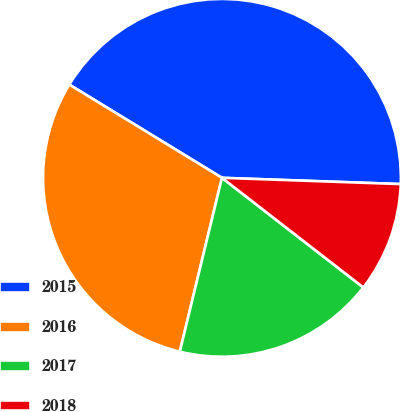Convert chart. <chart><loc_0><loc_0><loc_500><loc_500><pie_chart><fcel>2015<fcel>2016<fcel>2017<fcel>2018<nl><fcel>41.83%<fcel>29.94%<fcel>18.29%<fcel>9.94%<nl></chart> 